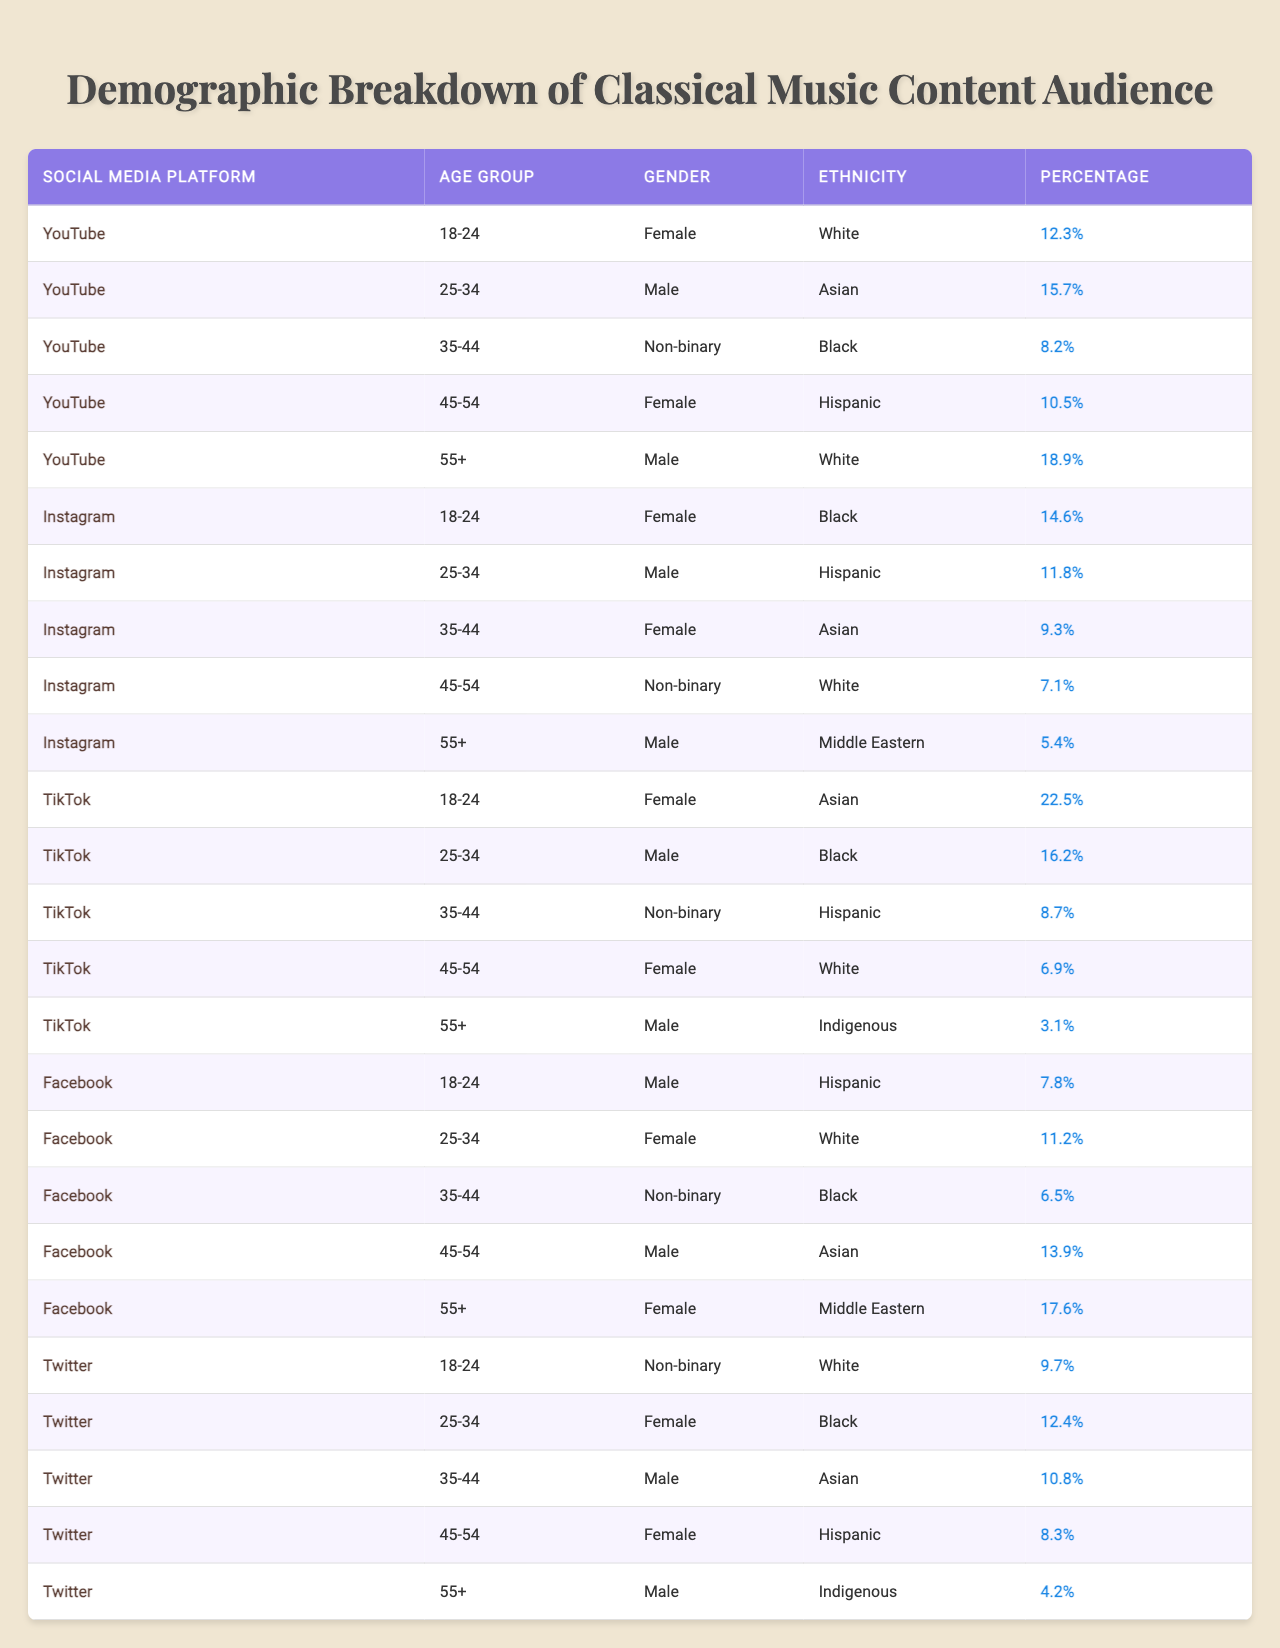What platform has the highest percentage of 18-24-year-old females? By looking at the row for the 18-24 age group under each platform, we see that YouTube has 12.3%, Instagram has 14.6%, TikTok has 22.5%, Facebook has 7.8%, and Twitter does not have an entry for females in this age group. Thus, TikTok has the highest percentage.
Answer: TikTok What is the percentage of non-binary individuals aged 35-44 on YouTube? The table indicates that for the 35-44 age group on YouTube, the percentage of non-binary individuals is 8.2%.
Answer: 8.2% Which platform has the lowest percentage of males aged 55 and above? Reviewing the rows for the 55+ age group for males across platforms: YouTube has 18.9%, TikTok has 3.1%, Facebook has 17.6%, and Twitter has 4.2%. Thus, TikTok has the lowest percentage.
Answer: TikTok What is the combined percentage of females aged 25-34 across all platforms? The relevant percentages from the table for females aged 25-34 are: YouTube (N/A), Instagram (11.8%), TikTok (N/A), Facebook (11.2%), and Twitter (12.4%). Adding these gives 11.8 + 11.2 + 12.4 = 35.4%.
Answer: 35.4% Does the percentage of Asian males aged 45-54 exceed 10% across any of the platforms? Checking the table, we see that only Facebook has Asian males in the 45-54 age group, with a percentage of 13.9%. Since this is greater than 10%, the answer is yes.
Answer: Yes What is the average percentage of Hispanic females aged 45-54 across all platforms? For Hispanic females aged 45-54, the percentages are: YouTube (10.5%), Instagram (N/A), TikTok (N/A), Facebook (N/A), and Twitter (8.3%). The average is (10.5 + 8.3) / 2 = 9.4%.
Answer: 9.4% Which age group has the highest representation of Asian individuals on TikTok? Checking the table for TikTok, the age groups show Asian individuals at 18-24 (22.5%), 25-34 (N/A), 35-44 (8.7%), 45-54 (N/A), and 55+ (N/A). The highest percentage is in the 18-24 age group.
Answer: 18-24 How many total males did we see in the 18-24 age group across all platforms? The percentages for males aged 18-24 are: YouTube (N/A), Instagram (N/A), TikTok (16.2%), Facebook (7.8%), and Twitter (N/A). Therefore, the only platform with males in this age group is TikTok (16.2%) and Facebook (7.8%), summing to 16.2 + 7.8 = 24%.
Answer: 24% 